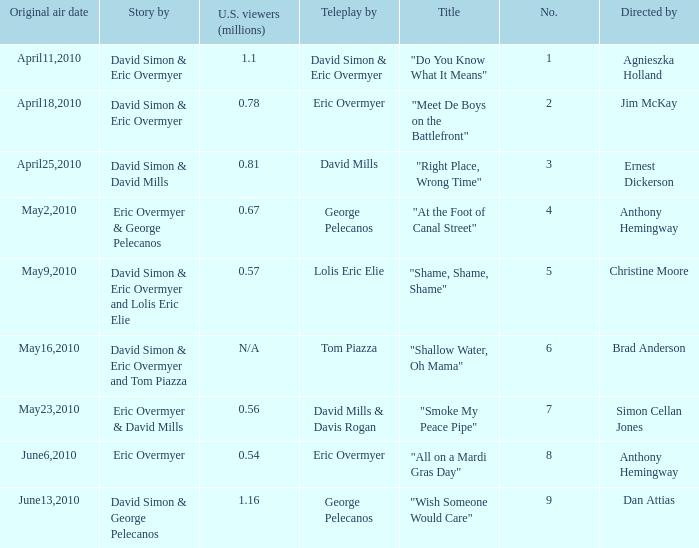Name the teleplay for  david simon & eric overmyer and tom piazza Tom Piazza. 